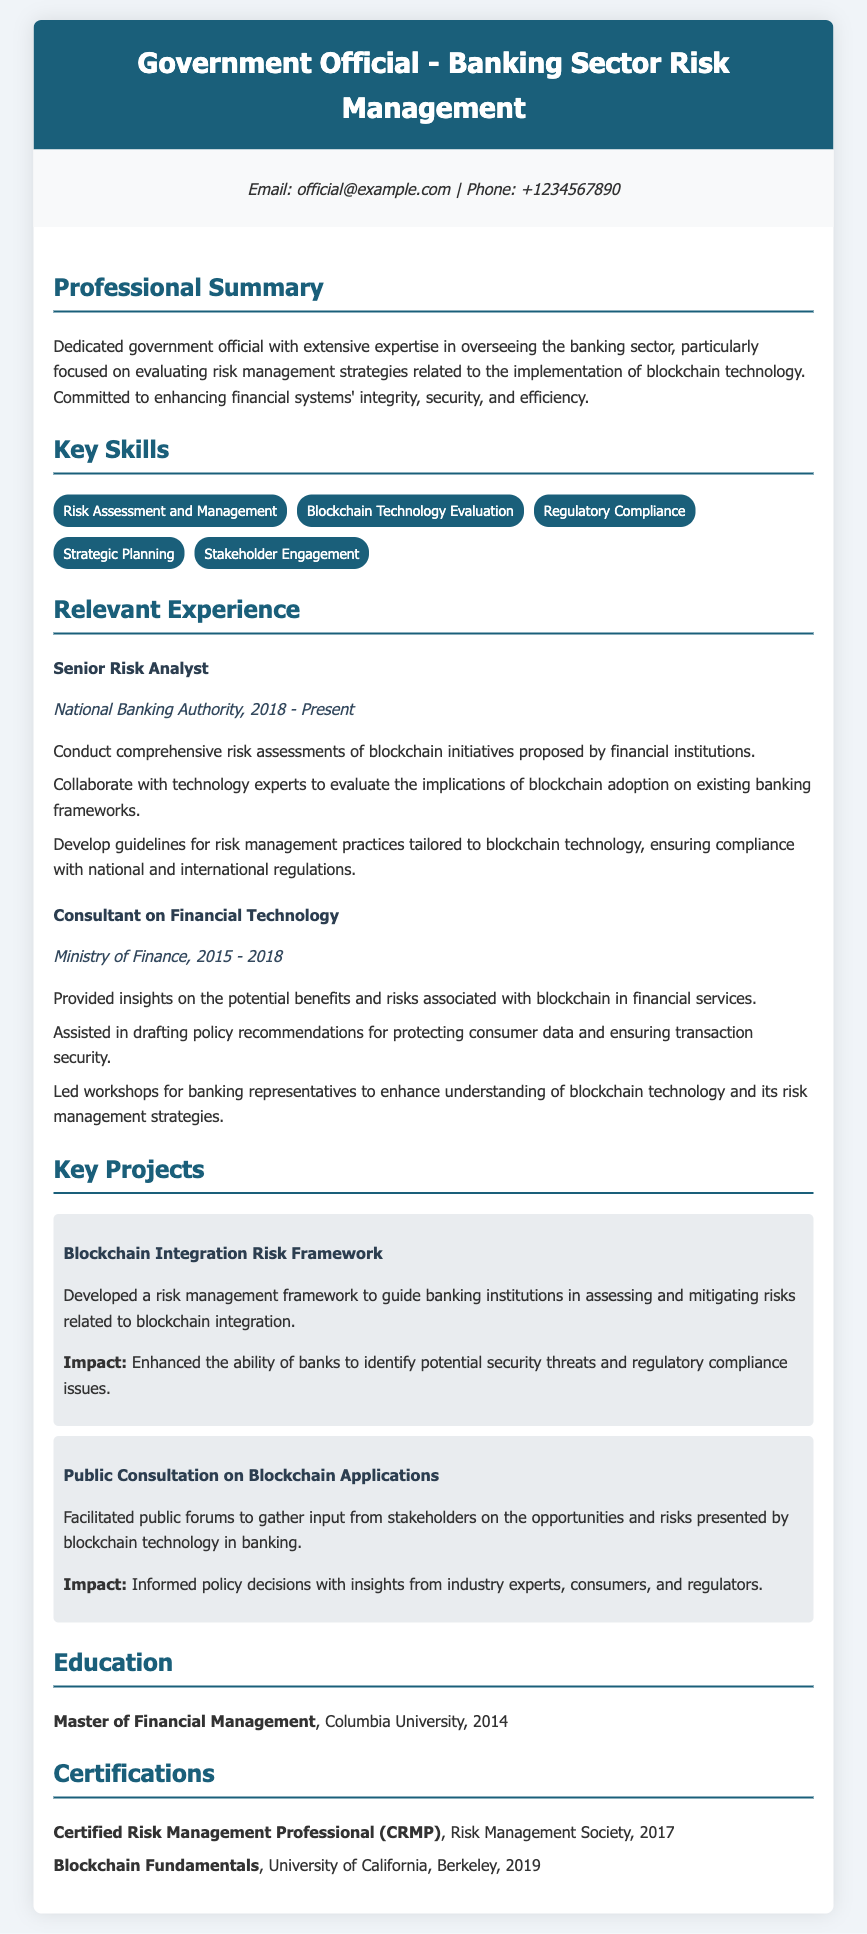What is the title of the resume? The title of the resume is indicated at the top of the document, reflecting the individual's role and focus.
Answer: Government Official - Banking Sector Risk Management What is the email address provided? The email address is found in the contact information section of the document.
Answer: official@example.com What certification was obtained in 2019? The certification listed under certifications is specified with the year it was earned.
Answer: Blockchain Fundamentals In what year did the individual start working at the National Banking Authority? The year of employment at the National Banking Authority is mentioned in the relevant experience section.
Answer: 2018 What is one key skill listed in the resume? The key skills section contains several specific skills relevant to the individual's expertise.
Answer: Risk Assessment and Management What was the impact of the "Blockchain Integration Risk Framework" project? The impact of the project is stated clearly in the project description, highlighting its significance.
Answer: Enhanced the ability of banks to identify potential security threats and regulatory compliance issues Which university did the individual attend for their master's degree? The education section provides the name of the university where the individual obtained their degree.
Answer: Columbia University How many years did the individual work as a Consultant on Financial Technology? The duration of employment in the consulting position is specified in the experience section of the document.
Answer: 3 years 